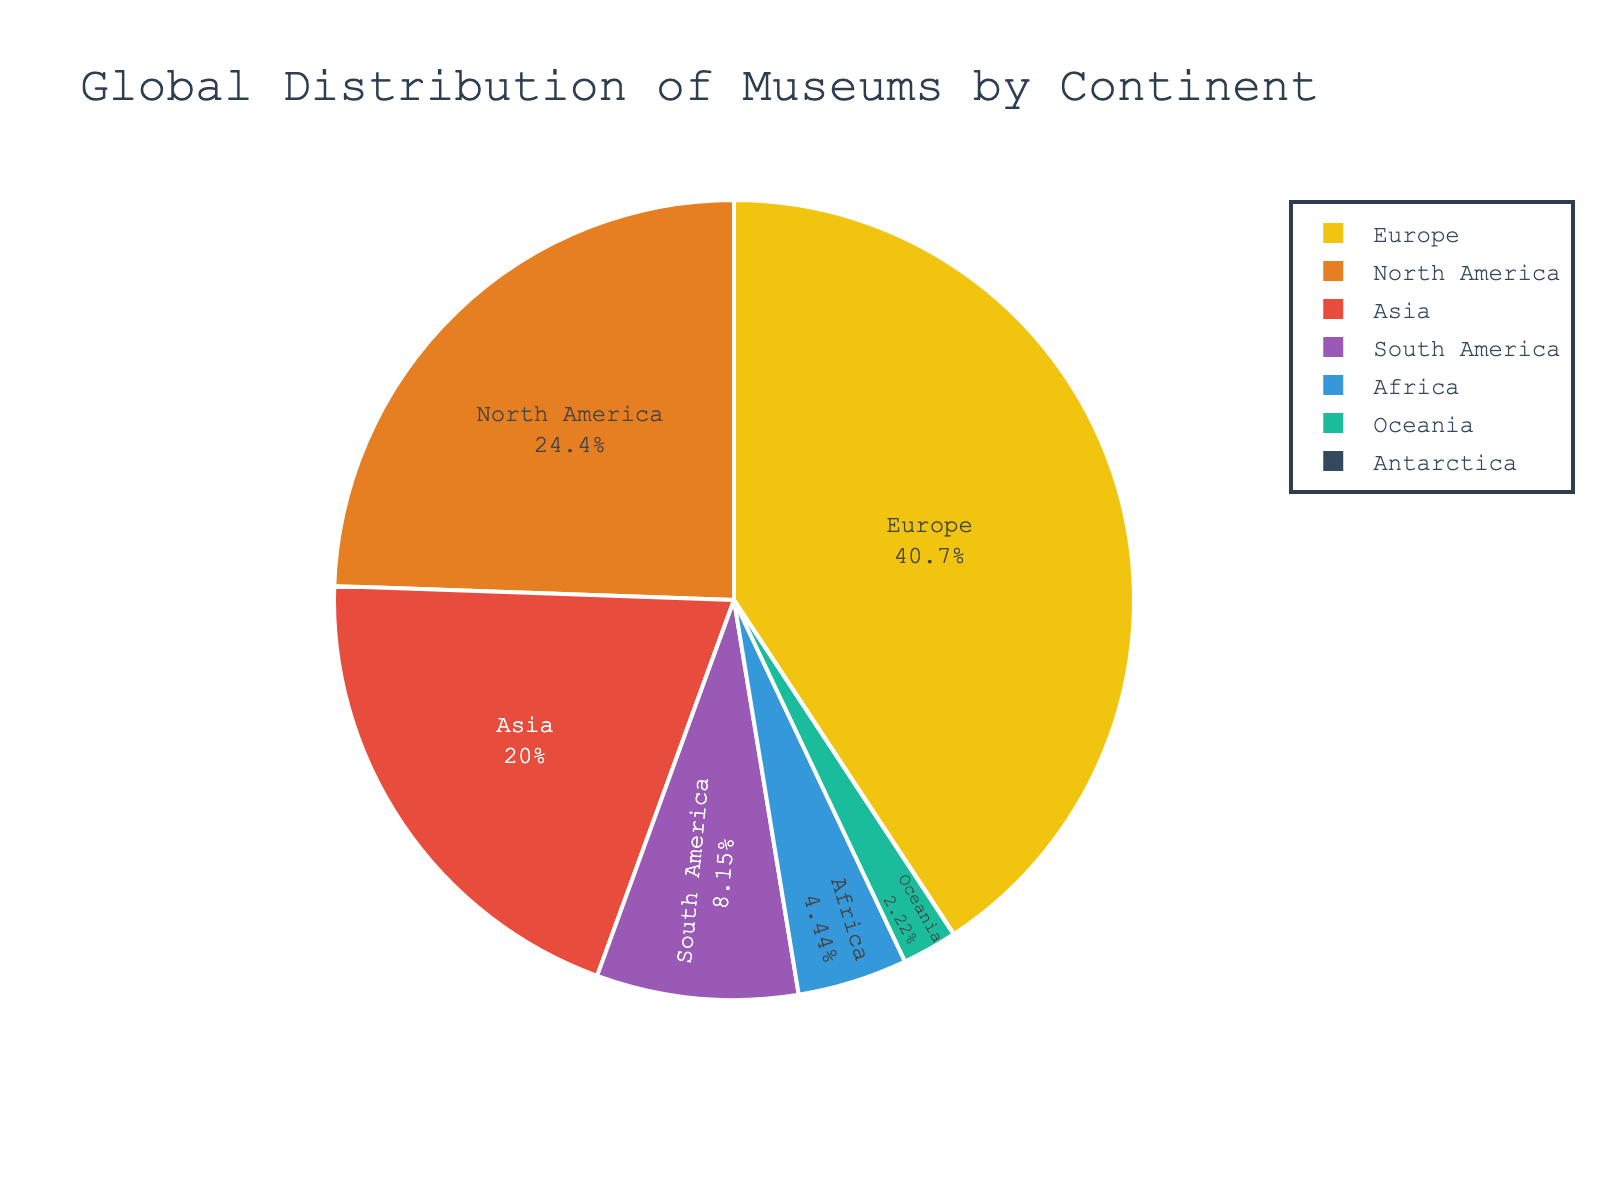What percentage of museums are in Asia? The figure shows the percentage of museums in each continent. By looking at the segment labeled Asia and the percentage indicated, you can find the answer.
Answer: 19.4% Which continent has roughly double the number of museums as Oceania? To find the answer, look at the number of museums in Oceania, which is 3000. Search for the continent with approximately twice this number. South America, with 11000, is the closest match as double of 3000 is 6000, and we look for the next closest data point.
Answer: South America What is the combined percentage of museums in Europe and North America? Add the percentages of museums in Europe and North America. If Europe has around 50.7% and North America has around 30.4%, the combined percentage is the sum of these two values.
Answer: 81.1% How many more museums does North America have compared to Africa? Subtract the number of museums in Africa (6000) from the number of museums in North America (33000). The result will give the difference.
Answer: 27000 Which continents have less than 10% of the world's museums each? Identify the segments on the pie chart that represent less than 10% each. From the chart, Asia, South America, Africa, Oceania, and Antarctica all have less than 10%. Verify the smallest representing < 10%.
Answer: Asia, South America, Africa, Oceania, and Antarctica What is the ratio of museums in Europe to museums in Oceania? Compare the number of museums in Europe (55000) to those in Oceania (3000). The ratio is found by dividing the number in Europe by the number in Oceania.
Answer: 18.3 : 1 If Africa and Oceania combined their number of museums, what percentage of the total would they represent? First, sum the number of museums in Africa (6000) and Oceania (3000) to get 9000. Then, calculate the percentage this represents out of the total number of museums. Total is 135010. The percentage is (9000/135010) * 100.
Answer: 6.7% Which continent has the smallest slice on the pie chart? Observe the pie chart and identify the smallest segment, which represents Antarctica with only 10 museums.
Answer: Antarctica Would Europe and North America together make up more than 75% of the total museums? Calculate the sum of the percentages of Europe and North America: 50.7% (Europe) and 30.4% (North America). Compare their sum to 75%.
Answer: Yes Is the number of museums in North America more than twice the number in South America? Multiply the number of museums in South America (11000) by 2 to get 22000. Compare this to the number of museums in North America (33000). Since 33000 > 22000, the answer is yes.
Answer: Yes 